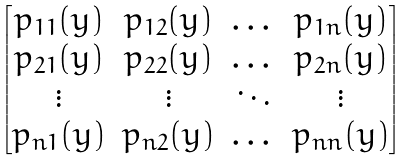Convert formula to latex. <formula><loc_0><loc_0><loc_500><loc_500>\begin{bmatrix} p _ { 1 1 } ( y ) & p _ { 1 2 } ( y ) & \dots & p _ { 1 n } ( y ) \\ p _ { 2 1 } ( y ) & p _ { 2 2 } ( y ) & \dots & p _ { 2 n } ( y ) \\ \vdots & \vdots & \ddots & \vdots \\ p _ { n 1 } ( y ) & p _ { n 2 } ( y ) & \dots & p _ { n n } ( y ) \end{bmatrix}</formula> 